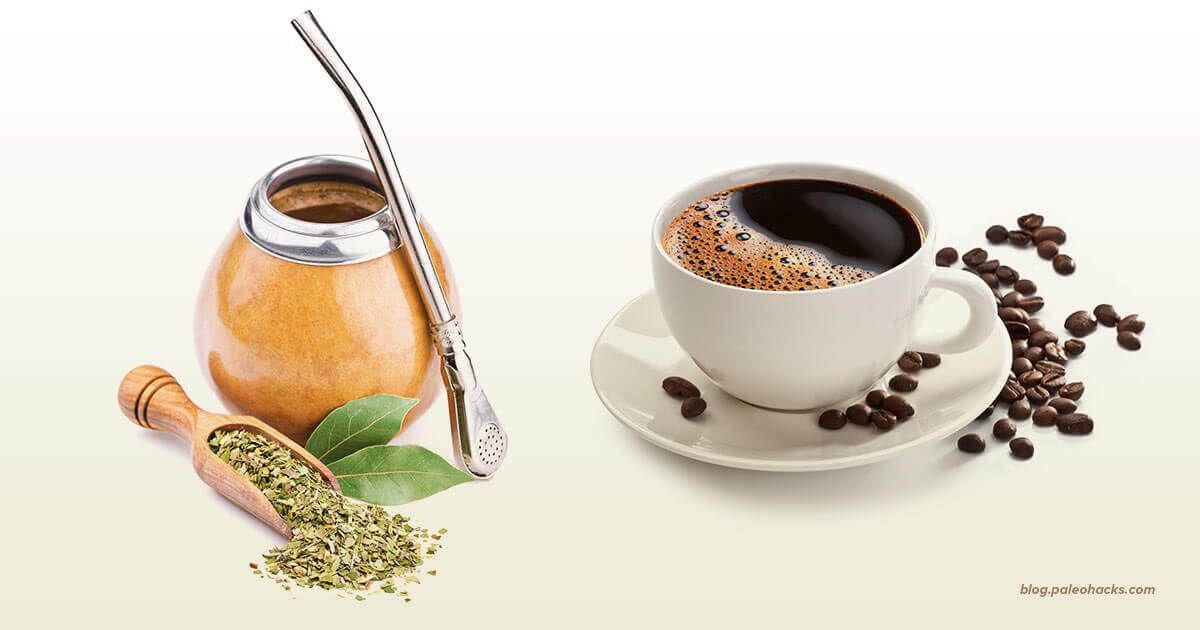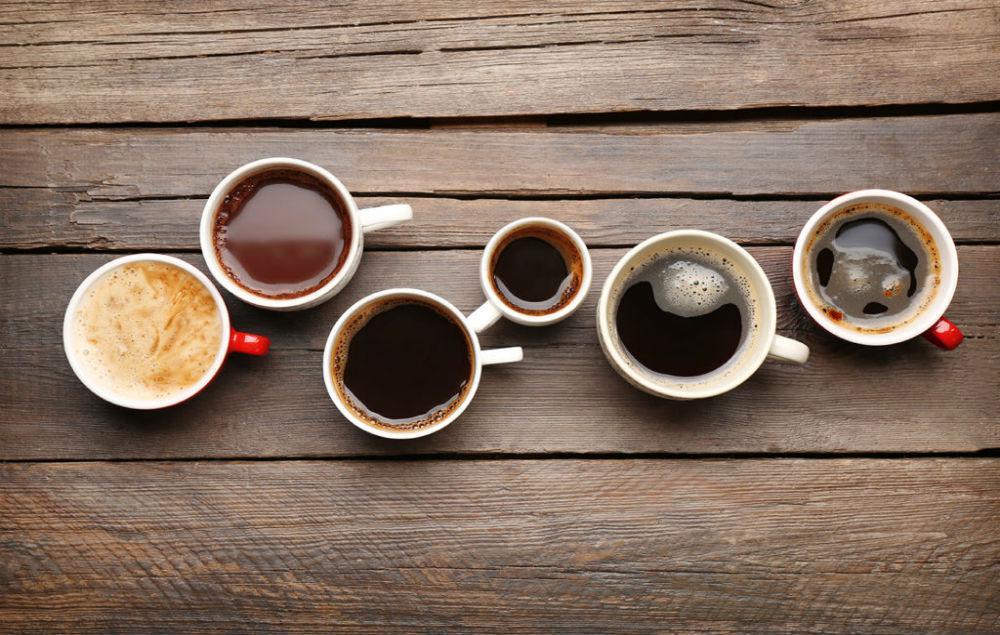The first image is the image on the left, the second image is the image on the right. Evaluate the accuracy of this statement regarding the images: "The left and right image contains a total of no more than ten cups.". Is it true? Answer yes or no. Yes. The first image is the image on the left, the second image is the image on the right. For the images displayed, is the sentence "Have mugs have coffee inside them in one of the pictures." factually correct? Answer yes or no. Yes. 